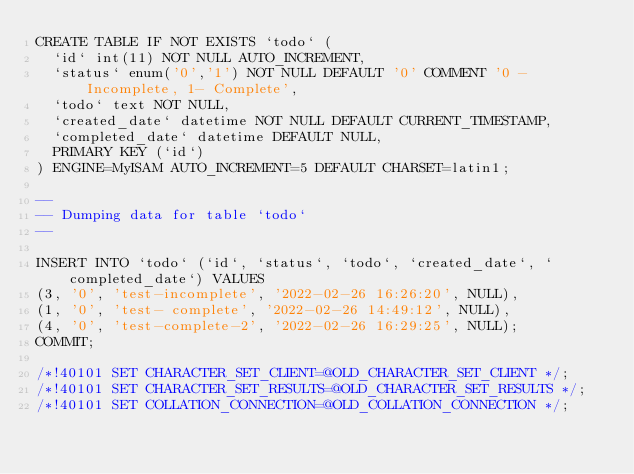Convert code to text. <code><loc_0><loc_0><loc_500><loc_500><_SQL_>CREATE TABLE IF NOT EXISTS `todo` (
  `id` int(11) NOT NULL AUTO_INCREMENT,
  `status` enum('0','1') NOT NULL DEFAULT '0' COMMENT '0 - Incomplete, 1- Complete',
  `todo` text NOT NULL,
  `created_date` datetime NOT NULL DEFAULT CURRENT_TIMESTAMP,
  `completed_date` datetime DEFAULT NULL,
  PRIMARY KEY (`id`)
) ENGINE=MyISAM AUTO_INCREMENT=5 DEFAULT CHARSET=latin1;

--
-- Dumping data for table `todo`
--

INSERT INTO `todo` (`id`, `status`, `todo`, `created_date`, `completed_date`) VALUES
(3, '0', 'test-incomplete', '2022-02-26 16:26:20', NULL),
(1, '0', 'test- complete', '2022-02-26 14:49:12', NULL),
(4, '0', 'test-complete-2', '2022-02-26 16:29:25', NULL);
COMMIT;

/*!40101 SET CHARACTER_SET_CLIENT=@OLD_CHARACTER_SET_CLIENT */;
/*!40101 SET CHARACTER_SET_RESULTS=@OLD_CHARACTER_SET_RESULTS */;
/*!40101 SET COLLATION_CONNECTION=@OLD_COLLATION_CONNECTION */;
</code> 